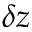<formula> <loc_0><loc_0><loc_500><loc_500>\delta z</formula> 